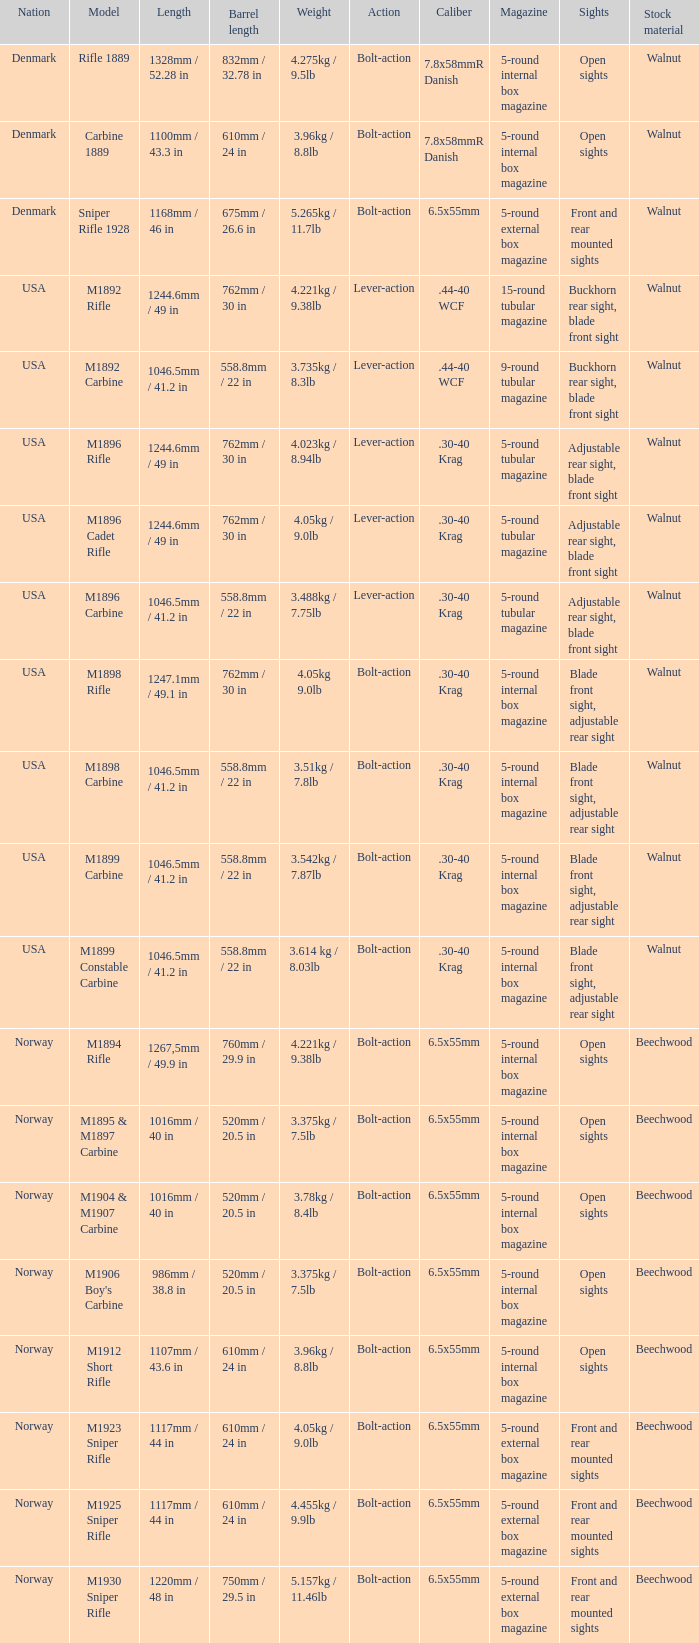What is Weight, when Length is 1168mm / 46 in? 5.265kg / 11.7lb. 